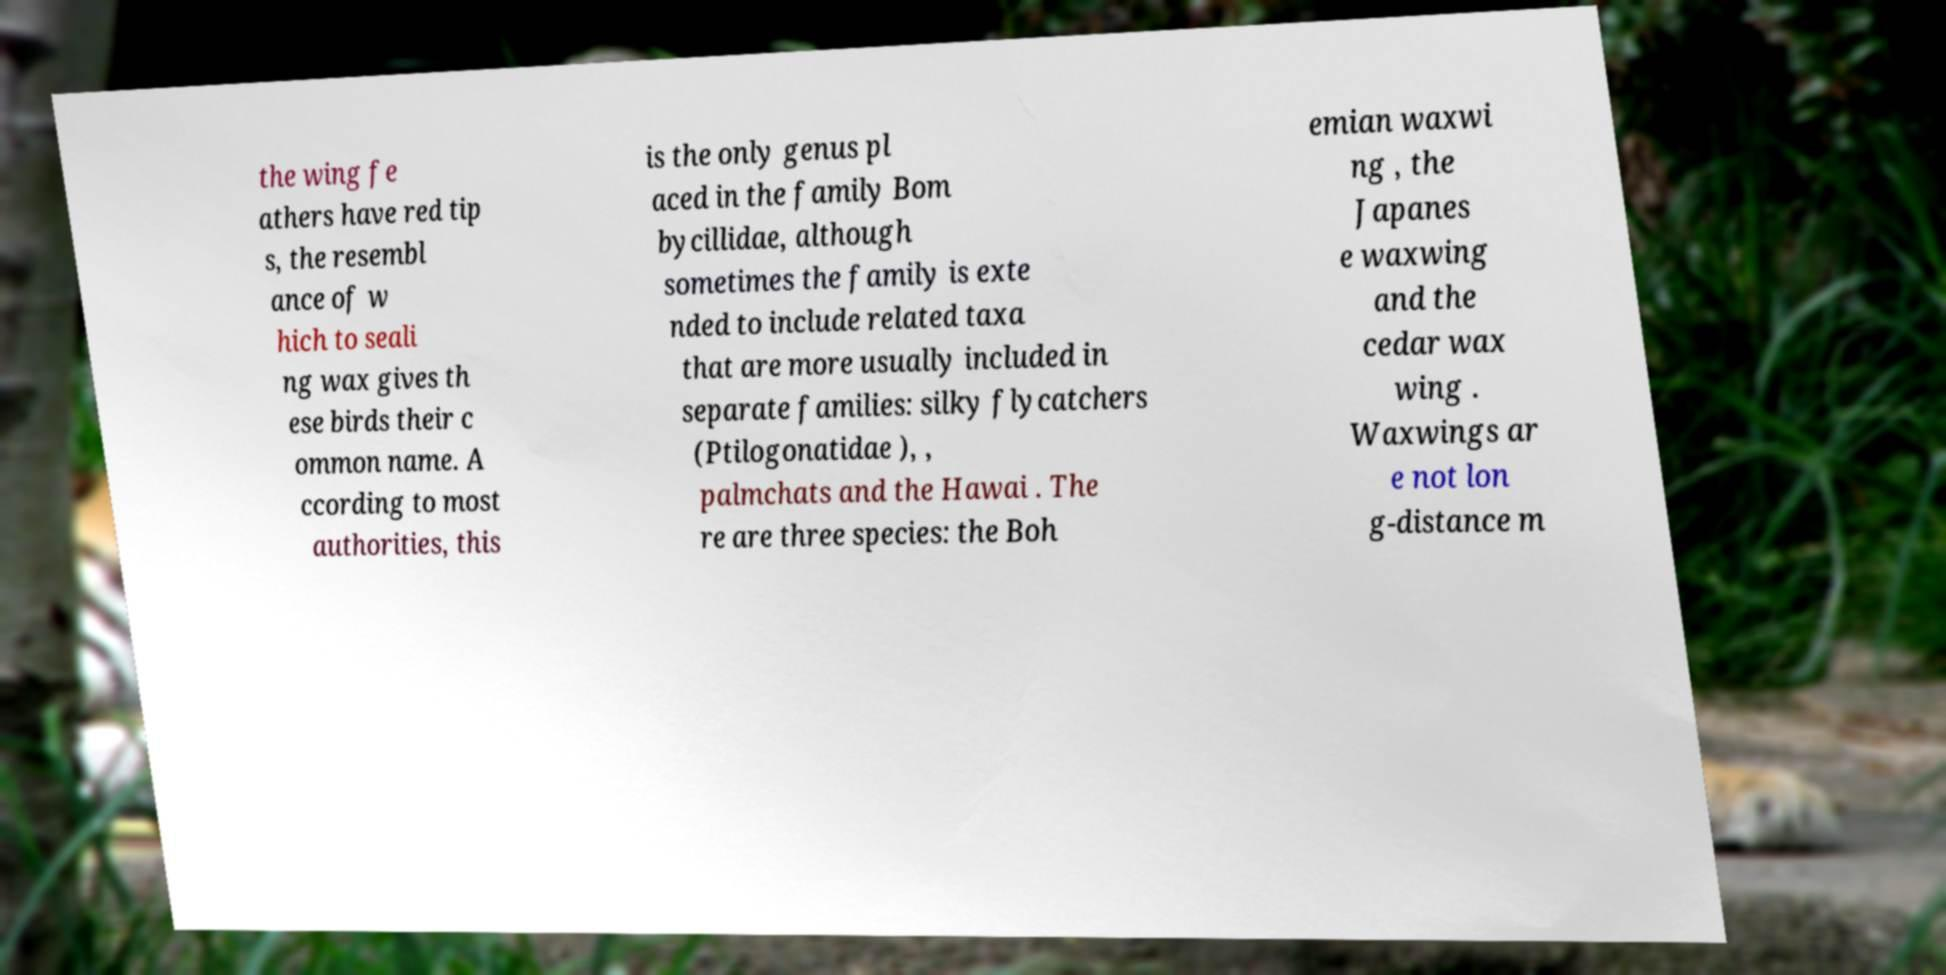Could you assist in decoding the text presented in this image and type it out clearly? the wing fe athers have red tip s, the resembl ance of w hich to seali ng wax gives th ese birds their c ommon name. A ccording to most authorities, this is the only genus pl aced in the family Bom bycillidae, although sometimes the family is exte nded to include related taxa that are more usually included in separate families: silky flycatchers (Ptilogonatidae ), , palmchats and the Hawai . The re are three species: the Boh emian waxwi ng , the Japanes e waxwing and the cedar wax wing . Waxwings ar e not lon g-distance m 